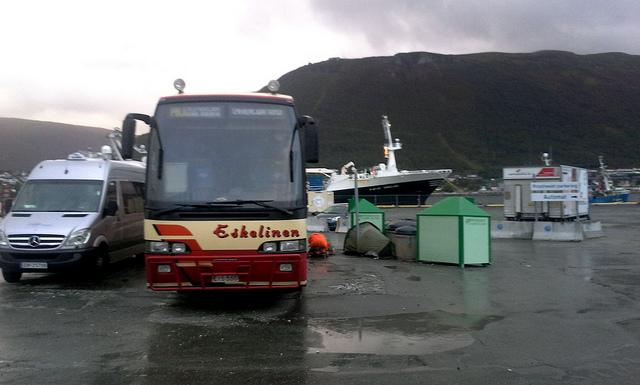What has caused the puddle in front of the bus? Please explain your reasoning. rain. Rain has caused a puddle of water to form under the front of the bus. 